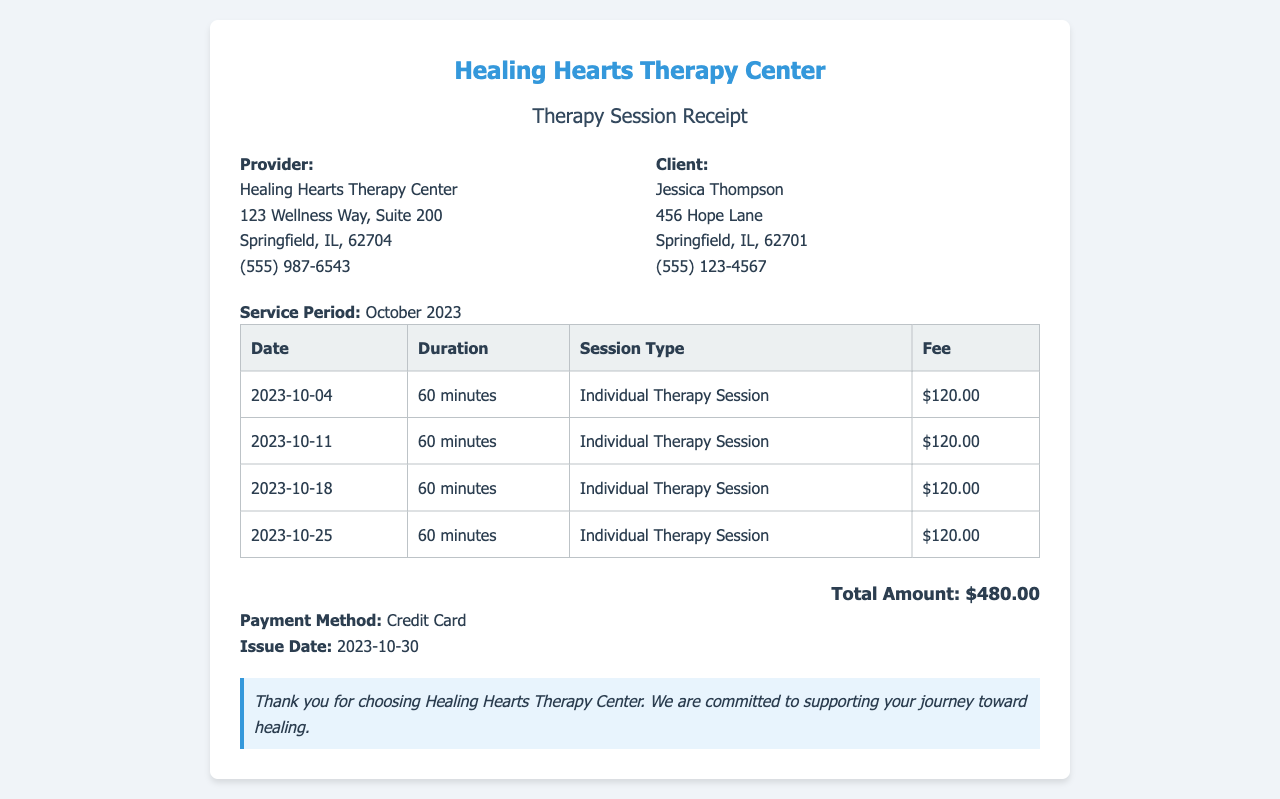What is the total amount billed? The total amount is mentioned at the bottom of the receipt as the final charge for the services rendered.
Answer: $480.00 Who is the client? The client's name is provided in the information section of the receipt.
Answer: Jessica Thompson What is the duration of each session? Each session has a consistent duration mentioned in the table.
Answer: 60 minutes What are the session dates? The receipt lists the specific dates of each therapy session in the table.
Answer: 2023-10-04, 2023-10-11, 2023-10-18, 2023-10-25 What type of therapy was provided? The type of service rendered is specified in the session type column of the table.
Answer: Individual Therapy Session What is the payment method? The payment method is stated at the bottom of the receipt.
Answer: Credit Card When was the receipt issued? The issue date is clearly stated on the receipt.
Answer: 2023-10-30 How many sessions were conducted in October? The total number of sessions is counted based on the entries in the table.
Answer: 4 